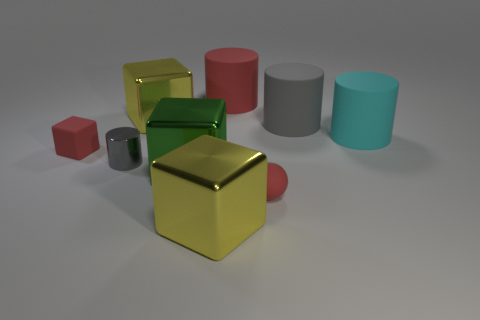How many objects are there in total in the image? There is a total of seven objects present in the image, including cubes, spheres, and cylinders. 